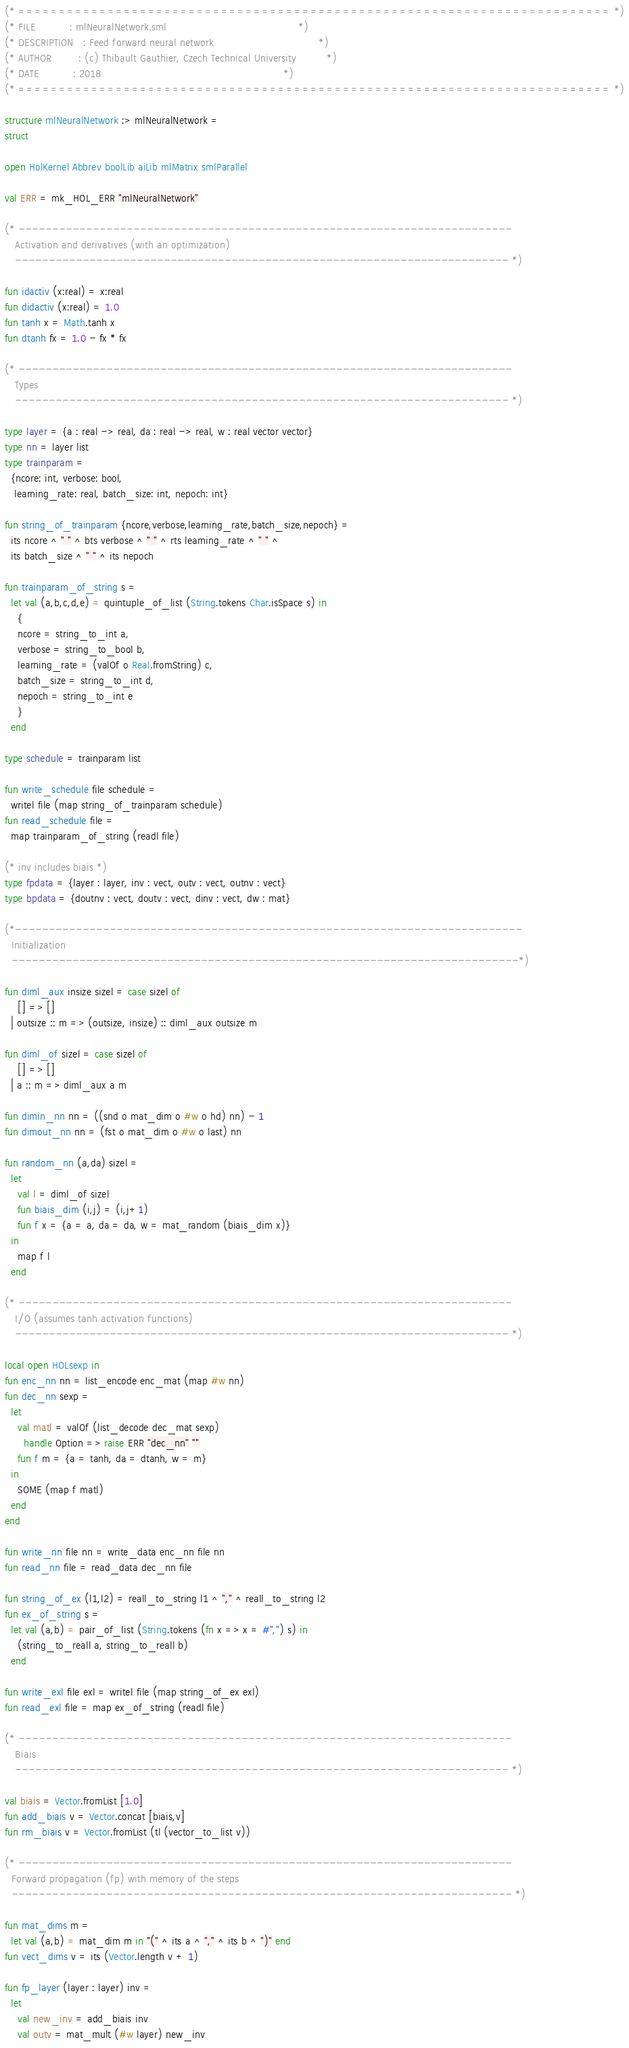<code> <loc_0><loc_0><loc_500><loc_500><_SML_>(* ========================================================================= *)
(* FILE          : mlNeuralNetwork.sml                                       *)
(* DESCRIPTION   : Feed forward neural network                               *)
(* AUTHOR        : (c) Thibault Gauthier, Czech Technical University         *)
(* DATE          : 2018                                                      *)
(* ========================================================================= *)

structure mlNeuralNetwork :> mlNeuralNetwork =
struct

open HolKernel Abbrev boolLib aiLib mlMatrix smlParallel

val ERR = mk_HOL_ERR "mlNeuralNetwork"

(* -------------------------------------------------------------------------
   Activation and derivatives (with an optimization)
   ------------------------------------------------------------------------- *)

fun idactiv (x:real) = x:real
fun didactiv (x:real) = 1.0
fun tanh x = Math.tanh x
fun dtanh fx = 1.0 - fx * fx

(* -------------------------------------------------------------------------
   Types
   ------------------------------------------------------------------------- *)

type layer = {a : real -> real, da : real -> real, w : real vector vector}
type nn = layer list
type trainparam =
  {ncore: int, verbose: bool,
   learning_rate: real, batch_size: int, nepoch: int}

fun string_of_trainparam {ncore,verbose,learning_rate,batch_size,nepoch} =
  its ncore ^ " " ^ bts verbose ^ " " ^ rts learning_rate ^ " " ^
  its batch_size ^ " " ^ its nepoch

fun trainparam_of_string s =
  let val (a,b,c,d,e) = quintuple_of_list (String.tokens Char.isSpace s) in
    {
    ncore = string_to_int a,
    verbose = string_to_bool b,
    learning_rate = (valOf o Real.fromString) c,
    batch_size = string_to_int d,
    nepoch = string_to_int e
    }
  end

type schedule = trainparam list

fun write_schedule file schedule =
  writel file (map string_of_trainparam schedule)
fun read_schedule file =
  map trainparam_of_string (readl file)

(* inv includes biais *)
type fpdata = {layer : layer, inv : vect, outv : vect, outnv : vect}
type bpdata = {doutnv : vect, doutv : vect, dinv : vect, dw : mat}

(*---------------------------------------------------------------------------
  Initialization
  ---------------------------------------------------------------------------*)

fun diml_aux insize sizel = case sizel of
    [] => []
  | outsize :: m => (outsize, insize) :: diml_aux outsize m

fun diml_of sizel = case sizel of
    [] => []
  | a :: m => diml_aux a m

fun dimin_nn nn = ((snd o mat_dim o #w o hd) nn) - 1
fun dimout_nn nn = (fst o mat_dim o #w o last) nn

fun random_nn (a,da) sizel =
  let
    val l = diml_of sizel
    fun biais_dim (i,j) = (i,j+1)
    fun f x = {a = a, da = da, w = mat_random (biais_dim x)}
  in
    map f l
  end

(* -------------------------------------------------------------------------
   I/O (assumes tanh activation functions)
   ------------------------------------------------------------------------- *)

local open HOLsexp in
fun enc_nn nn = list_encode enc_mat (map #w nn)
fun dec_nn sexp =
  let
    val matl = valOf (list_decode dec_mat sexp)
      handle Option => raise ERR "dec_nn" ""
    fun f m = {a = tanh, da = dtanh, w = m}
  in
    SOME (map f matl)
  end
end

fun write_nn file nn = write_data enc_nn file nn
fun read_nn file = read_data dec_nn file

fun string_of_ex (l1,l2) = reall_to_string l1 ^ "," ^ reall_to_string l2
fun ex_of_string s =
  let val (a,b) = pair_of_list (String.tokens (fn x => x = #",") s) in
    (string_to_reall a, string_to_reall b)
  end

fun write_exl file exl = writel file (map string_of_ex exl)
fun read_exl file = map ex_of_string (readl file)

(* -------------------------------------------------------------------------
   Biais
   ------------------------------------------------------------------------- *)

val biais = Vector.fromList [1.0]
fun add_biais v = Vector.concat [biais,v]
fun rm_biais v = Vector.fromList (tl (vector_to_list v))

(* -------------------------------------------------------------------------
  Forward propagation (fp) with memory of the steps
  -------------------------------------------------------------------------- *)

fun mat_dims m =
  let val (a,b) = mat_dim m in "(" ^ its a ^ "," ^ its b ^ ")" end
fun vect_dims v = its (Vector.length v + 1)

fun fp_layer (layer : layer) inv =
  let
    val new_inv = add_biais inv
    val outv = mat_mult (#w layer) new_inv</code> 